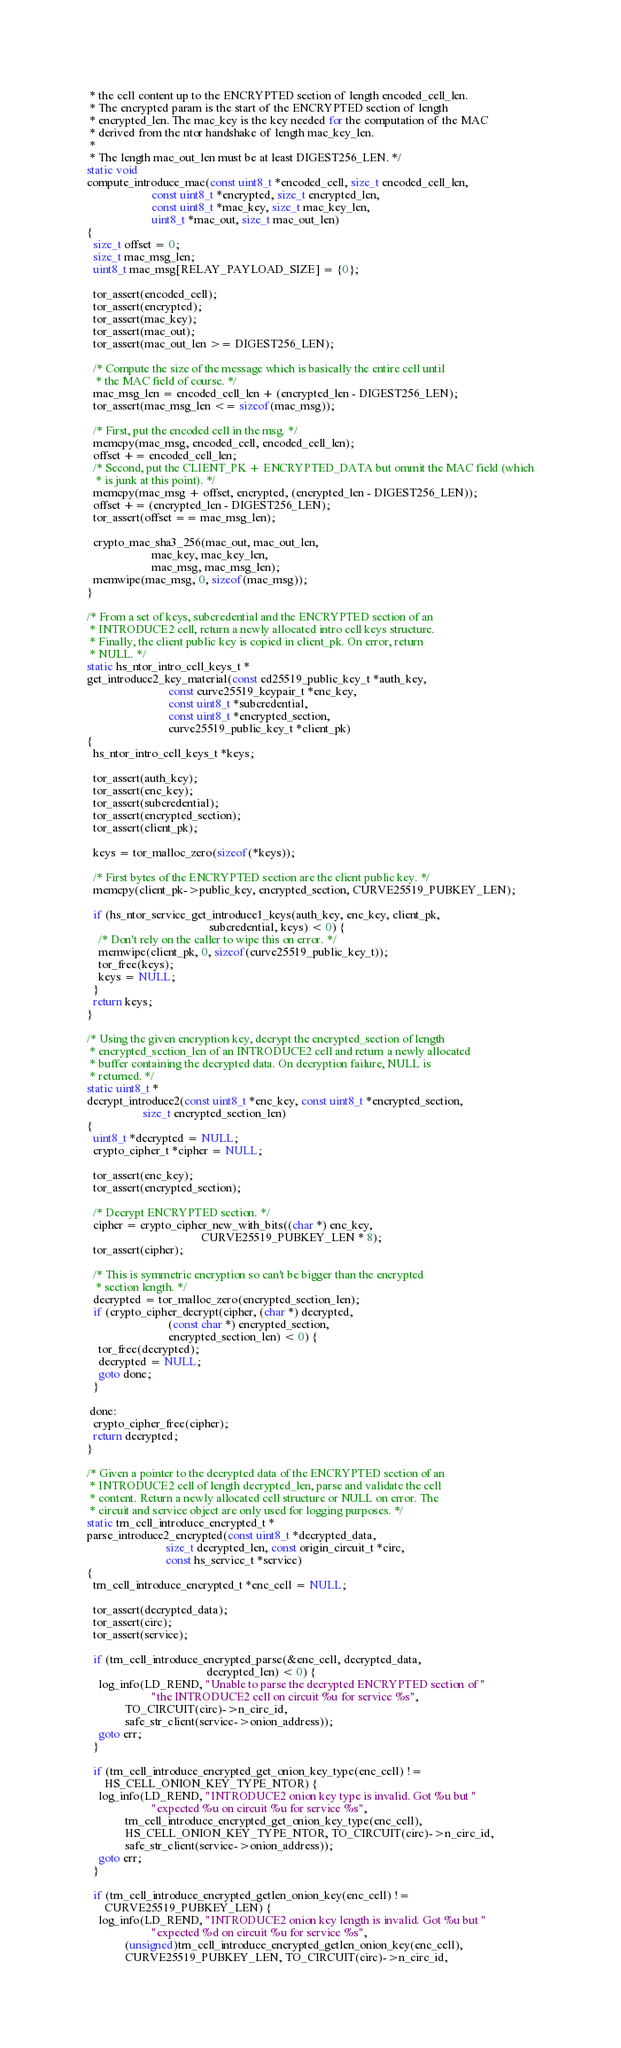<code> <loc_0><loc_0><loc_500><loc_500><_C_> * the cell content up to the ENCRYPTED section of length encoded_cell_len.
 * The encrypted param is the start of the ENCRYPTED section of length
 * encrypted_len. The mac_key is the key needed for the computation of the MAC
 * derived from the ntor handshake of length mac_key_len.
 *
 * The length mac_out_len must be at least DIGEST256_LEN. */
static void
compute_introduce_mac(const uint8_t *encoded_cell, size_t encoded_cell_len,
                      const uint8_t *encrypted, size_t encrypted_len,
                      const uint8_t *mac_key, size_t mac_key_len,
                      uint8_t *mac_out, size_t mac_out_len)
{
  size_t offset = 0;
  size_t mac_msg_len;
  uint8_t mac_msg[RELAY_PAYLOAD_SIZE] = {0};

  tor_assert(encoded_cell);
  tor_assert(encrypted);
  tor_assert(mac_key);
  tor_assert(mac_out);
  tor_assert(mac_out_len >= DIGEST256_LEN);

  /* Compute the size of the message which is basically the entire cell until
   * the MAC field of course. */
  mac_msg_len = encoded_cell_len + (encrypted_len - DIGEST256_LEN);
  tor_assert(mac_msg_len <= sizeof(mac_msg));

  /* First, put the encoded cell in the msg. */
  memcpy(mac_msg, encoded_cell, encoded_cell_len);
  offset += encoded_cell_len;
  /* Second, put the CLIENT_PK + ENCRYPTED_DATA but ommit the MAC field (which
   * is junk at this point). */
  memcpy(mac_msg + offset, encrypted, (encrypted_len - DIGEST256_LEN));
  offset += (encrypted_len - DIGEST256_LEN);
  tor_assert(offset == mac_msg_len);

  crypto_mac_sha3_256(mac_out, mac_out_len,
                      mac_key, mac_key_len,
                      mac_msg, mac_msg_len);
  memwipe(mac_msg, 0, sizeof(mac_msg));
}

/* From a set of keys, subcredential and the ENCRYPTED section of an
 * INTRODUCE2 cell, return a newly allocated intro cell keys structure.
 * Finally, the client public key is copied in client_pk. On error, return
 * NULL. */
static hs_ntor_intro_cell_keys_t *
get_introduce2_key_material(const ed25519_public_key_t *auth_key,
                            const curve25519_keypair_t *enc_key,
                            const uint8_t *subcredential,
                            const uint8_t *encrypted_section,
                            curve25519_public_key_t *client_pk)
{
  hs_ntor_intro_cell_keys_t *keys;

  tor_assert(auth_key);
  tor_assert(enc_key);
  tor_assert(subcredential);
  tor_assert(encrypted_section);
  tor_assert(client_pk);

  keys = tor_malloc_zero(sizeof(*keys));

  /* First bytes of the ENCRYPTED section are the client public key. */
  memcpy(client_pk->public_key, encrypted_section, CURVE25519_PUBKEY_LEN);

  if (hs_ntor_service_get_introduce1_keys(auth_key, enc_key, client_pk,
                                          subcredential, keys) < 0) {
    /* Don't rely on the caller to wipe this on error. */
    memwipe(client_pk, 0, sizeof(curve25519_public_key_t));
    tor_free(keys);
    keys = NULL;
  }
  return keys;
}

/* Using the given encryption key, decrypt the encrypted_section of length
 * encrypted_section_len of an INTRODUCE2 cell and return a newly allocated
 * buffer containing the decrypted data. On decryption failure, NULL is
 * returned. */
static uint8_t *
decrypt_introduce2(const uint8_t *enc_key, const uint8_t *encrypted_section,
                   size_t encrypted_section_len)
{
  uint8_t *decrypted = NULL;
  crypto_cipher_t *cipher = NULL;

  tor_assert(enc_key);
  tor_assert(encrypted_section);

  /* Decrypt ENCRYPTED section. */
  cipher = crypto_cipher_new_with_bits((char *) enc_key,
                                       CURVE25519_PUBKEY_LEN * 8);
  tor_assert(cipher);

  /* This is symmetric encryption so can't be bigger than the encrypted
   * section length. */
  decrypted = tor_malloc_zero(encrypted_section_len);
  if (crypto_cipher_decrypt(cipher, (char *) decrypted,
                            (const char *) encrypted_section,
                            encrypted_section_len) < 0) {
    tor_free(decrypted);
    decrypted = NULL;
    goto done;
  }

 done:
  crypto_cipher_free(cipher);
  return decrypted;
}

/* Given a pointer to the decrypted data of the ENCRYPTED section of an
 * INTRODUCE2 cell of length decrypted_len, parse and validate the cell
 * content. Return a newly allocated cell structure or NULL on error. The
 * circuit and service object are only used for logging purposes. */
static trn_cell_introduce_encrypted_t *
parse_introduce2_encrypted(const uint8_t *decrypted_data,
                           size_t decrypted_len, const origin_circuit_t *circ,
                           const hs_service_t *service)
{
  trn_cell_introduce_encrypted_t *enc_cell = NULL;

  tor_assert(decrypted_data);
  tor_assert(circ);
  tor_assert(service);

  if (trn_cell_introduce_encrypted_parse(&enc_cell, decrypted_data,
                                         decrypted_len) < 0) {
    log_info(LD_REND, "Unable to parse the decrypted ENCRYPTED section of "
                      "the INTRODUCE2 cell on circuit %u for service %s",
             TO_CIRCUIT(circ)->n_circ_id,
             safe_str_client(service->onion_address));
    goto err;
  }

  if (trn_cell_introduce_encrypted_get_onion_key_type(enc_cell) !=
      HS_CELL_ONION_KEY_TYPE_NTOR) {
    log_info(LD_REND, "INTRODUCE2 onion key type is invalid. Got %u but "
                      "expected %u on circuit %u for service %s",
             trn_cell_introduce_encrypted_get_onion_key_type(enc_cell),
             HS_CELL_ONION_KEY_TYPE_NTOR, TO_CIRCUIT(circ)->n_circ_id,
             safe_str_client(service->onion_address));
    goto err;
  }

  if (trn_cell_introduce_encrypted_getlen_onion_key(enc_cell) !=
      CURVE25519_PUBKEY_LEN) {
    log_info(LD_REND, "INTRODUCE2 onion key length is invalid. Got %u but "
                      "expected %d on circuit %u for service %s",
             (unsigned)trn_cell_introduce_encrypted_getlen_onion_key(enc_cell),
             CURVE25519_PUBKEY_LEN, TO_CIRCUIT(circ)->n_circ_id,</code> 